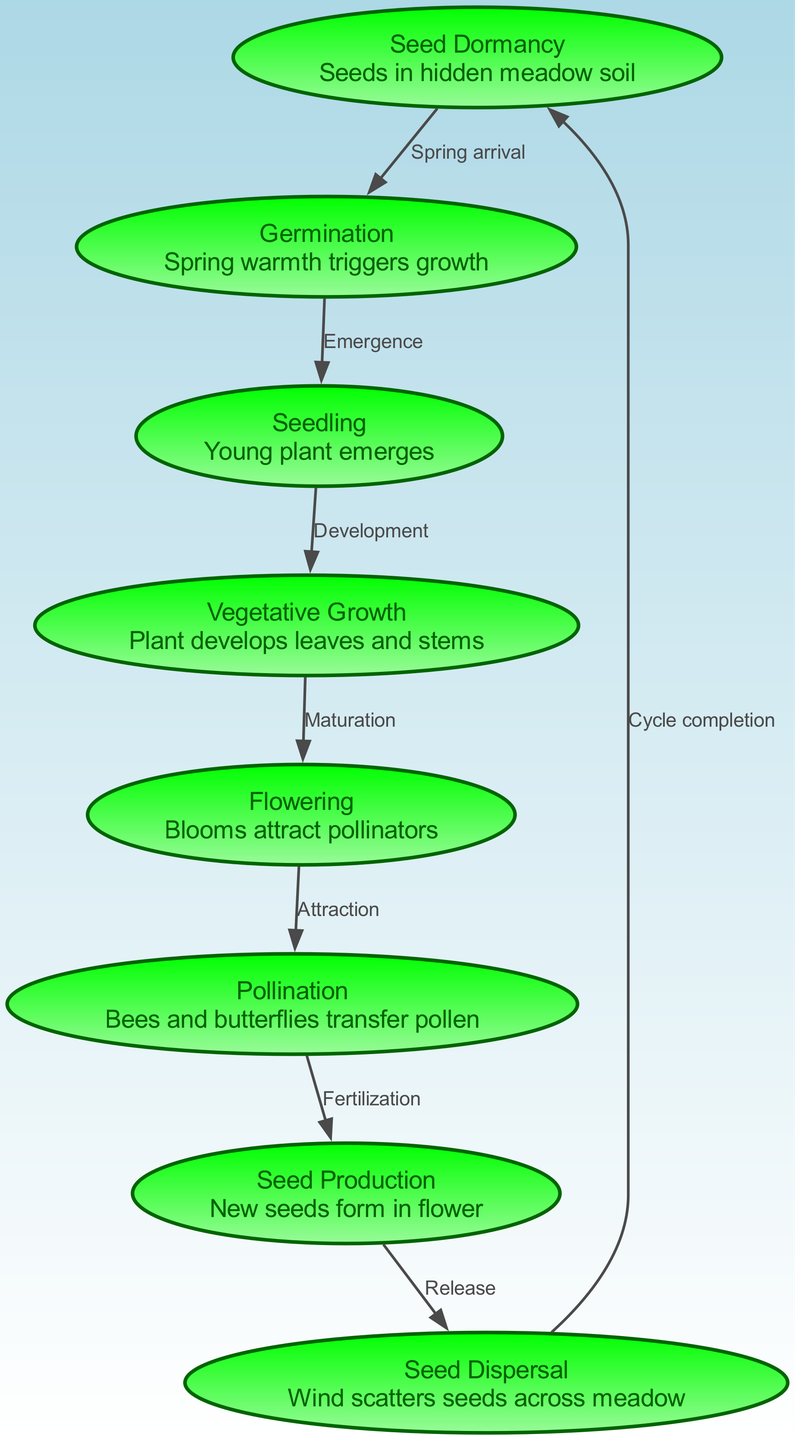What is the first stage in the lifecycle of Belgian wildflowers? The first stage is represented by the "Seed Dormancy" node. This node indicates that the lifecycle begins with seeds being present in the hidden meadow soil, ready for the right conditions to start growing.
Answer: Seed Dormancy How many nodes are in the diagram? By counting each unique stage represented in the nodes section of the data, we find that there are a total of eight nodes depicting different stages of the lifecycle.
Answer: Eight What do bees and butterflies do in the lifecycle? The "pollination" node describes this process where bees and butterflies transfer pollen, playing a critical role in the reproductive phase of the wildflowers.
Answer: Transfer pollen What happens after flowering in the lifecycle? Following the flowering stage, the diagram shows that the next phase is "Pollination," where bees and butterflies are involved in fertilizing the plant to enable seed production.
Answer: Pollination What is the relationship between seed production and seed dispersal? The edge connecting "Seed Production" and "Seed Dispersal" indicates that after seeds are produced within the flower, they are released and scattered by wind across the meadow.
Answer: Release How does germination lead to seedling development? The edge labeled "Emergence" links the "Germination" and "Seedling" nodes, indicating that once the seeds germinate, they grow into seedlings, marking their emergence as young plants.
Answer: Emergence What completes the lifecycle cycle in this diagram? The edge leading from "Dispersal" back to "Seed Dormancy" shows that the cycle is completed when seeds are scattered and fall back into the soil, starting the process over again.
Answer: Cycle completion What stage comes directly after vegetative growth? The diagram indicates that after the "Vegetative Growth" stage, the next phase is "Flowering," where the plants begin to bloom and attract pollinators.
Answer: Flowering 